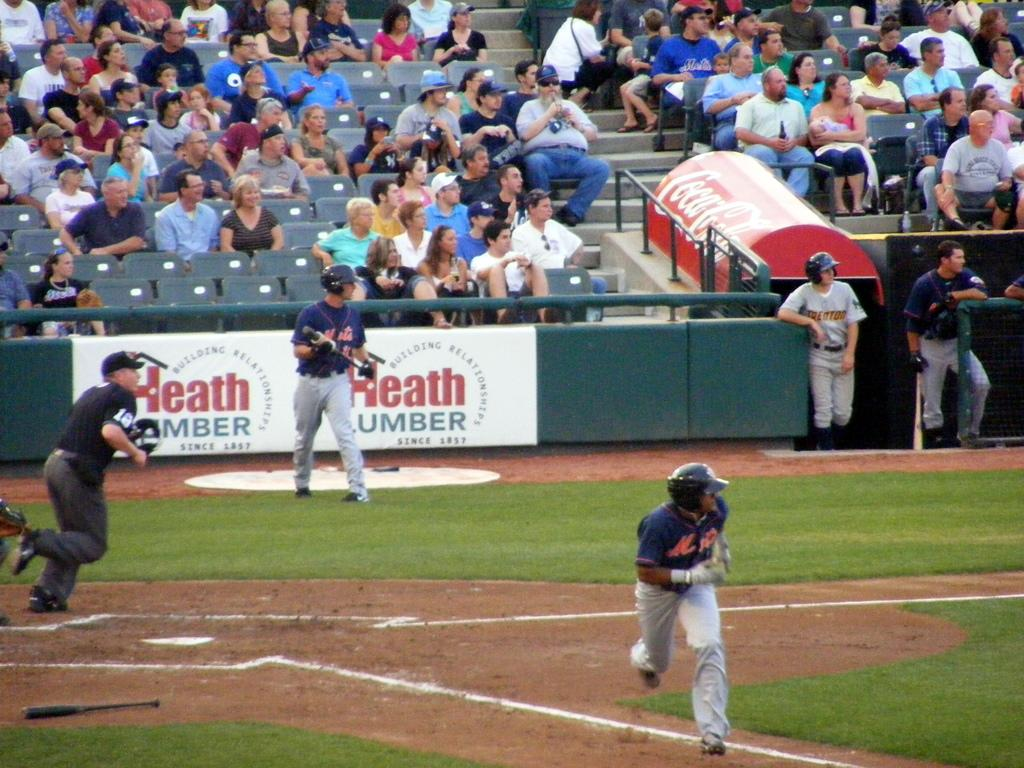Provide a one-sentence caption for the provided image. Mets baseball player getting ready to run the base. 